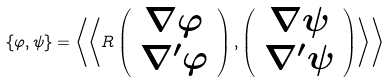<formula> <loc_0><loc_0><loc_500><loc_500>\left \{ \varphi , \psi \right \} = \left \langle \left \langle R \left ( \begin{array} { c } \nabla \varphi \\ \nabla ^ { \prime } \varphi \end{array} \right ) , \left ( \begin{array} { c } \nabla \psi \\ \nabla ^ { \prime } \psi \end{array} \right ) \right \rangle \right \rangle</formula> 